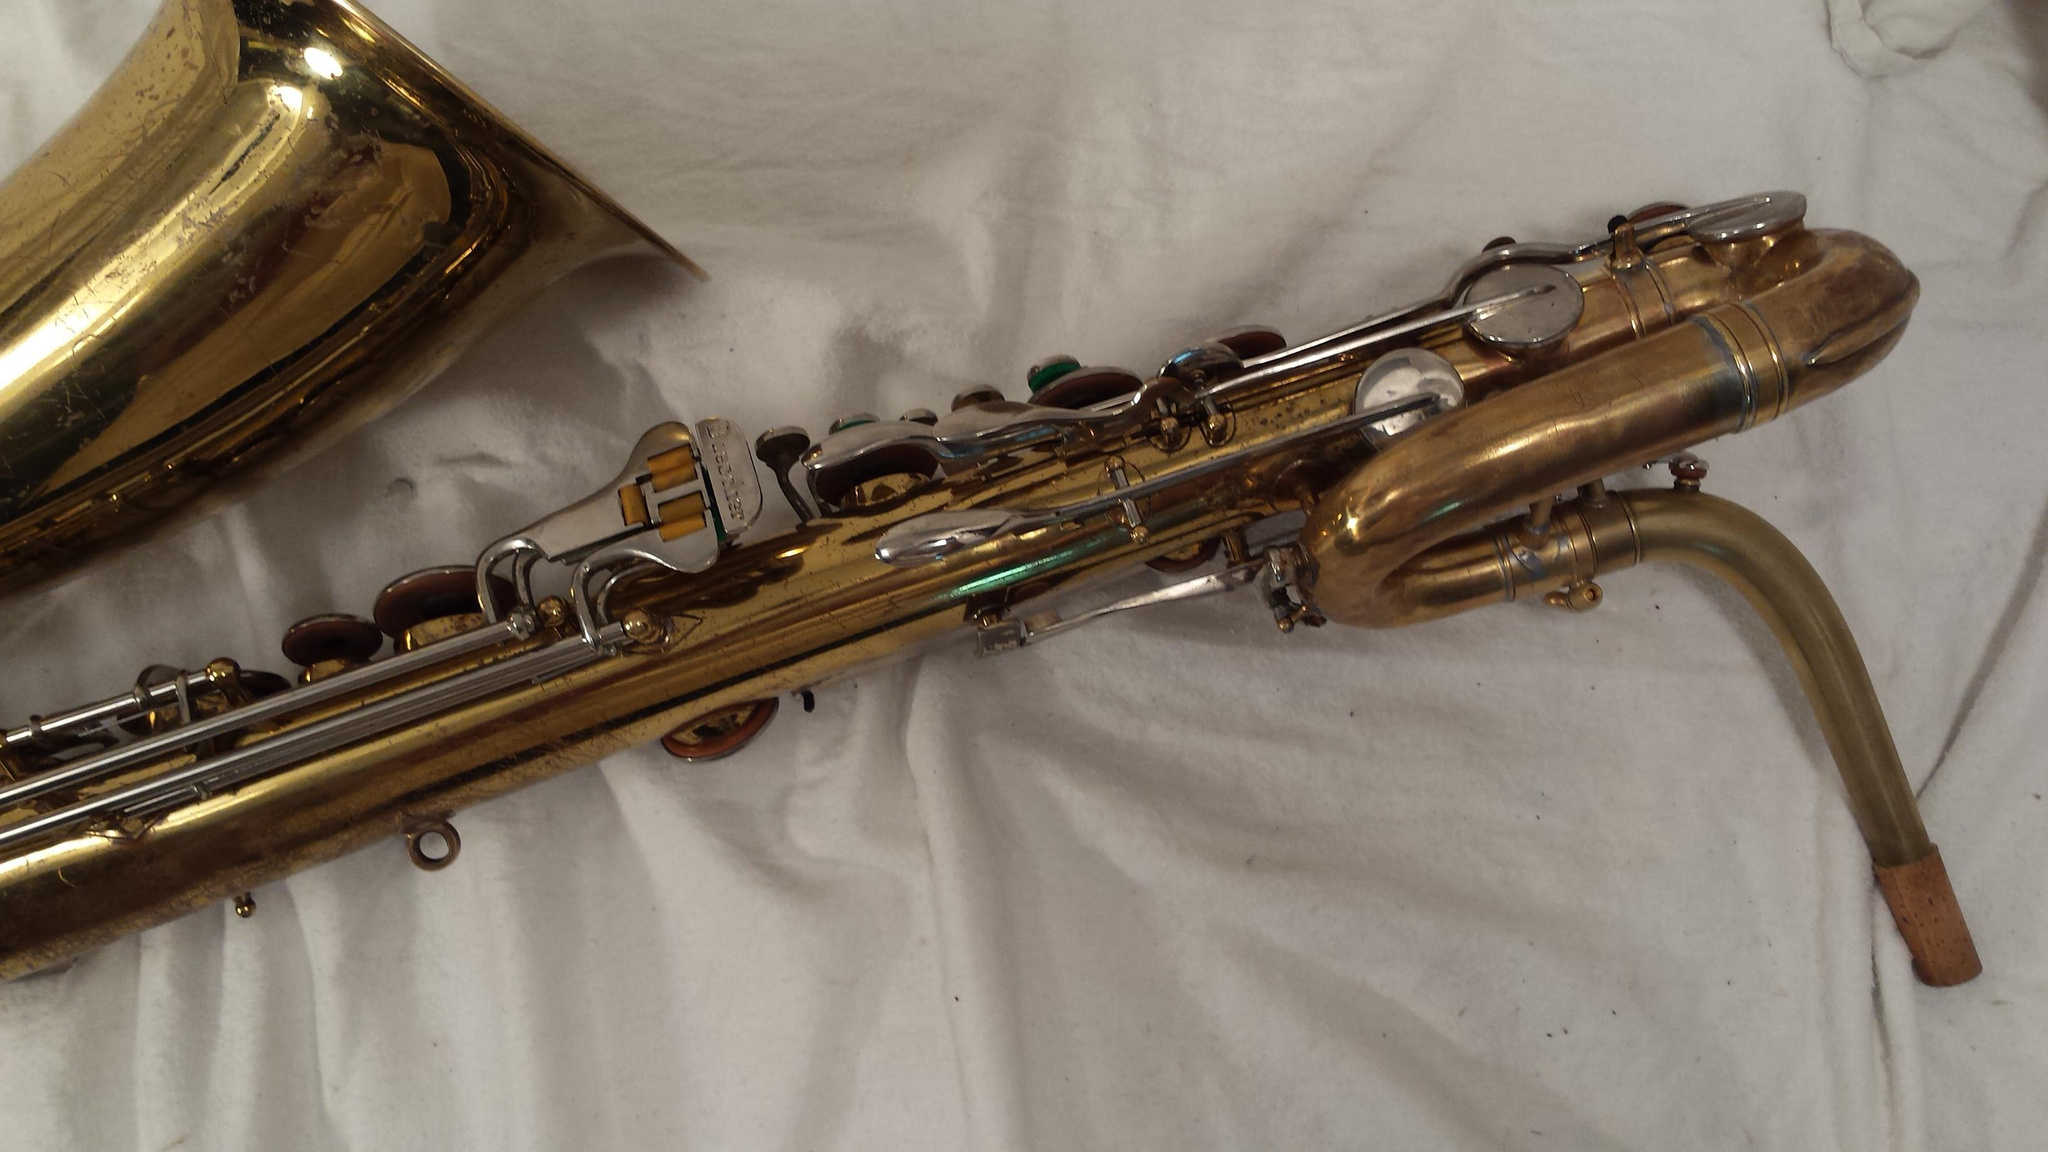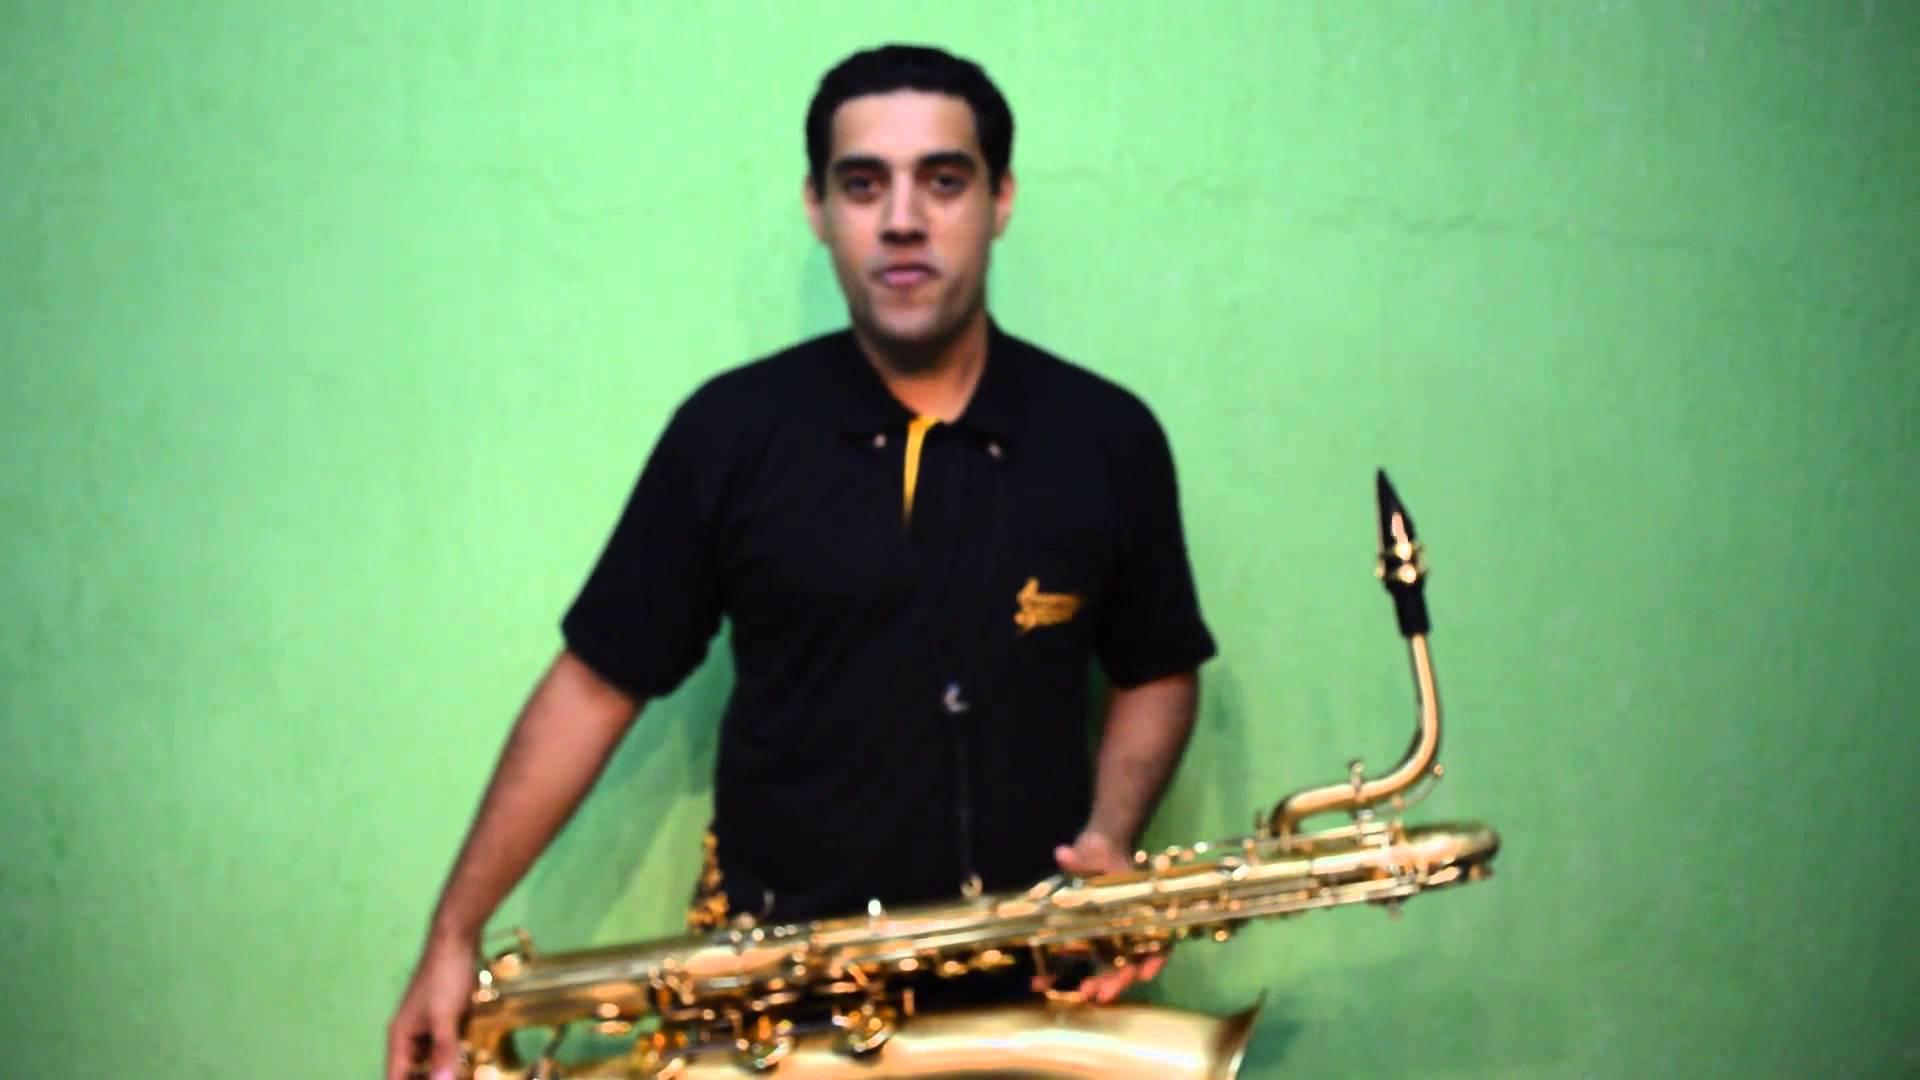The first image is the image on the left, the second image is the image on the right. Evaluate the accuracy of this statement regarding the images: "A man is holding the saxophone in the image on the right.". Is it true? Answer yes or no. Yes. The first image is the image on the left, the second image is the image on the right. Evaluate the accuracy of this statement regarding the images: "A man in a short-sleeved black shirt is holding a saxophone.". Is it true? Answer yes or no. Yes. 